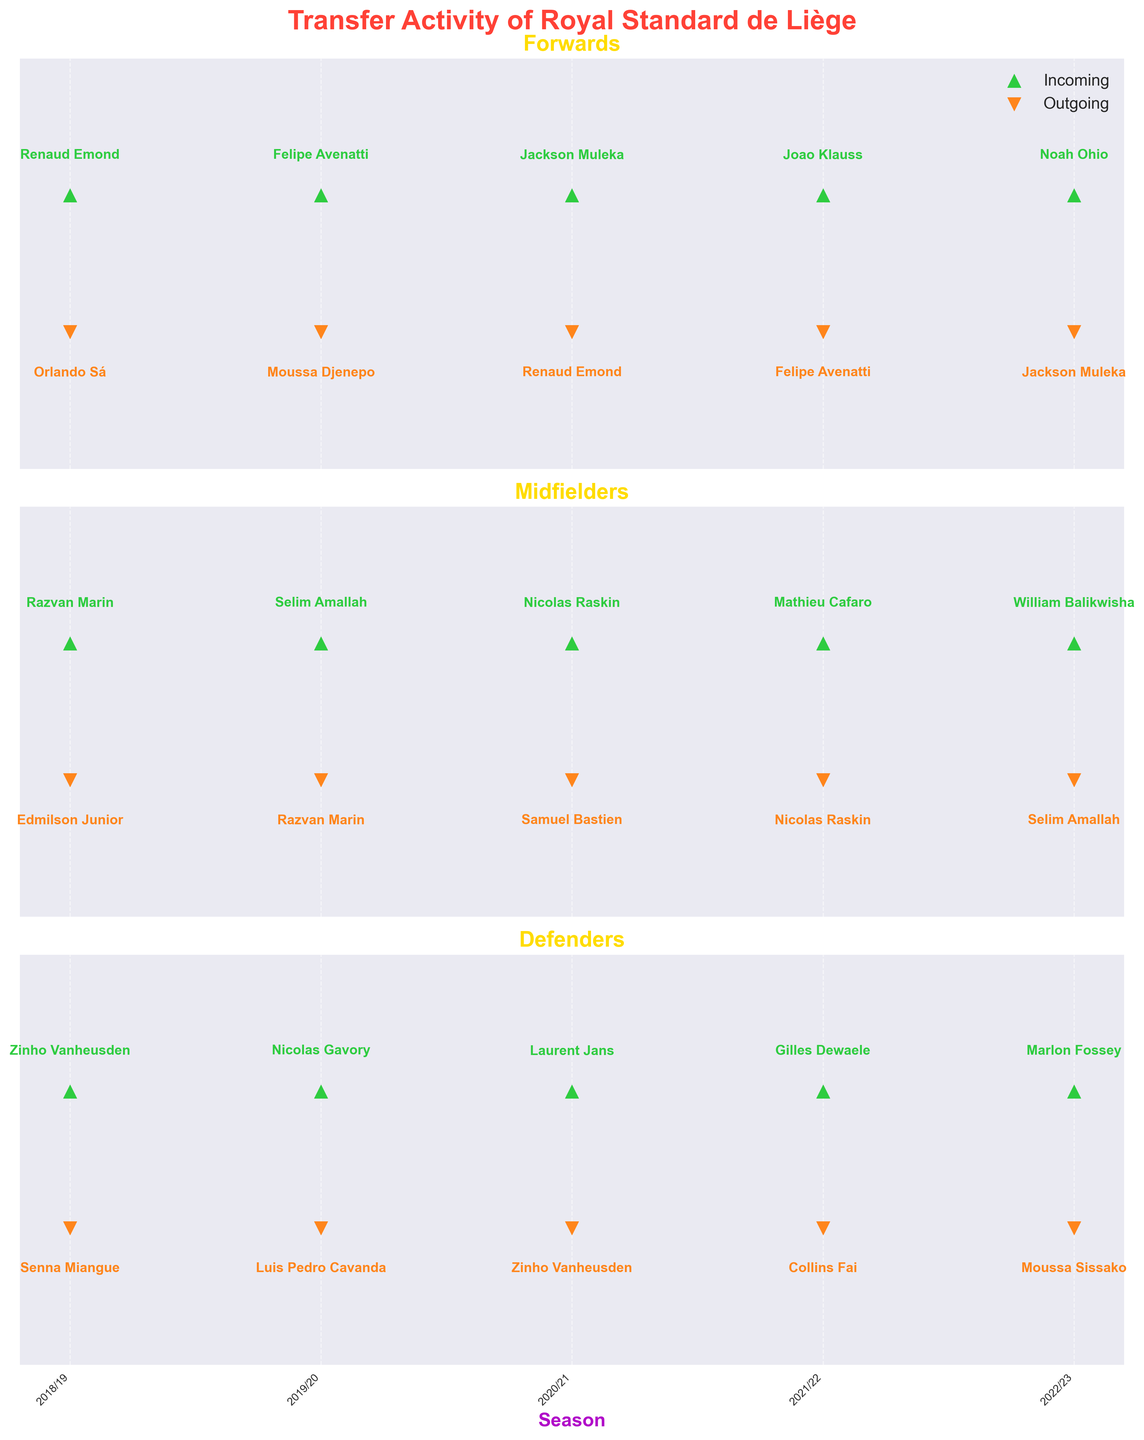Which season saw the incoming transfer of Razvan Marin? By looking at the subplot for midfielders, identify the season where Razvan Marin is marked as an incoming transfer near the top of the plot.
Answer: 2018/19 Who was the outgoing forward transfer in the 2020/21 season? In the subplot for forwards, identify who was marked as an outgoing transfer during the 2020/21 season near the bottom of the plot.
Answer: Renaud Emond How many different defenders were transferred in the 2019/20 season? Check the defenders' subplot and count both incoming and outgoing transfers indicated in the 2019/20 season.
Answer: 2 In which season did Nicolas Raskin transfer twice, and what were the directions? Check all subplots for midfielder transfers and find the season where Nicolas Raskin appears both as an incoming and outgoing transfer.
Answer: 2021/22 Which position had the most transfers in the 2021/22 season? Compare the number of transfers for forwards, midfielders, and defenders in the 2021/22 season in their respective subplots. Identify the position with the highest count.
Answer: Midfielder Who were the incoming and outgoing midfielder transfers in the 2022/23 season? Refer to the midfielder subplot and identify both the incoming and outgoing transfer names marked in the 2022/23 season.
Answer: William Balikwisha and Selim Amallah Which seasons had incoming forward transfers from Orlando Sá and Jackson Muleka? View the forward subplot and identify the seasons where Orlando Sá and Jackson Muleka were marked as incoming transfers.
Answer: Orlando Sá in 2018/19 and Jackson Muleka in 2020/21 What is the difference in the number of total transfers (incoming and outgoing) between forwards and defenders over all seasons? Count all incoming and outgoing transfers for forwards and defenders in their respective subplots across all seasons, then calculate the difference.
Answer: 1 Between the 2018/19 and 2022/23 seasons, which season had the most defender transfers? Review each season's defender subplot and tally the number of total transfers (both incoming and outgoing) to identify the season with the highest count.
Answer: 2018/19 How many outgoing transfers were there for forwards between 2018/19 and 2022/23? Sum up the outgoing forward transfers indicated in the forward subplot over all seasons between 2018/19 and 2022/23.
Answer: 4 